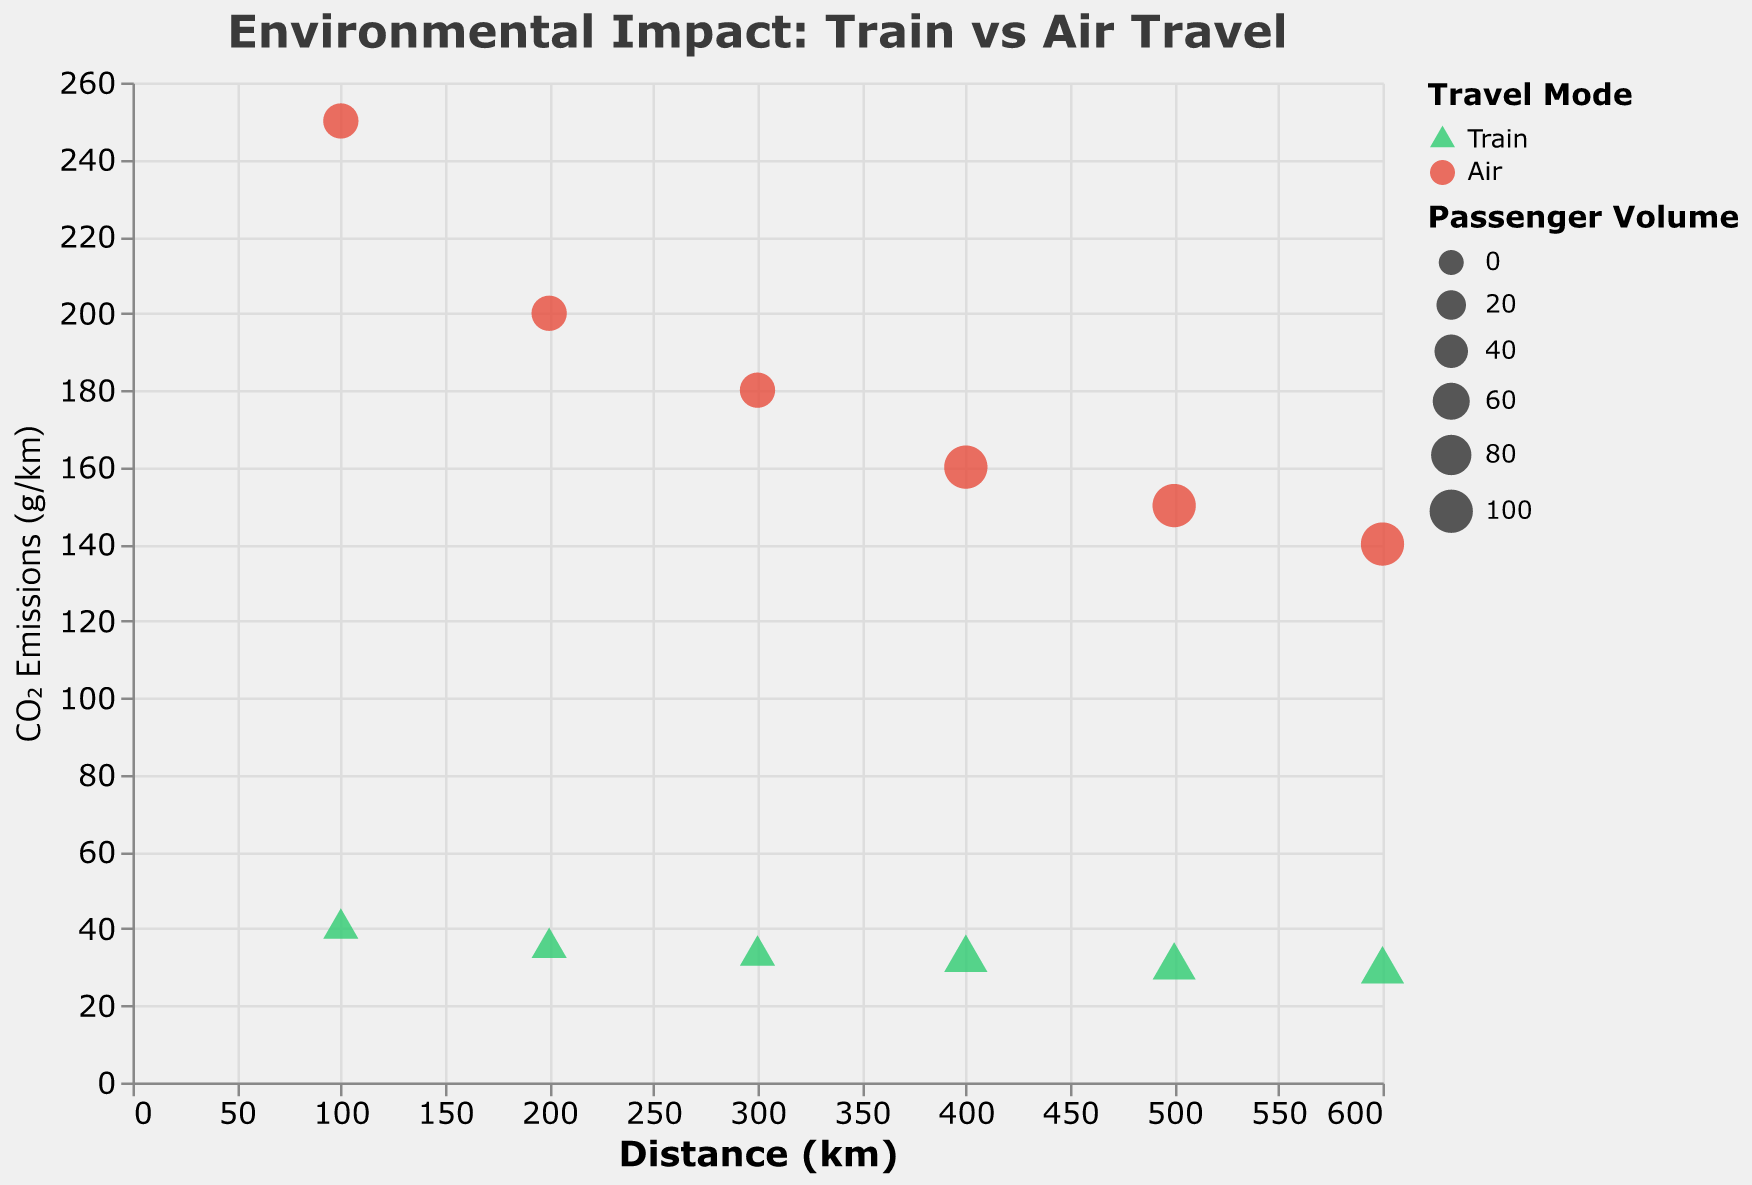What is the title of the figure? The title of the figure is displayed at the top of the plot and reads "Environmental Impact: Train vs Air Travel".
Answer: Environmental Impact: Train vs Air Travel How does the CO2 emissions per km for train travel change as the distance increases from 100 km to 600 km? The train’s CO2 emissions per km gradually decrease as the distance increases. From 40 g/km at 100 km to 29 g/km at 600 km.
Answer: It decreases What colors represent trains and air travel in the plot? The plot uses a color legend where green is used for trains and red is used for air travel.
Answer: Green and Red Which travel mode has higher CO2 emissions per km on a 300 km distance? For a 300 km distance, the CO2 emissions per km for air travel are 180 g/km, and for train travel are 33 g/km. Air travel has higher emissions.
Answer: Air travel How many different passenger volume sizes are used in the plot for train travel, and what are they? Train travel has two different passenger volume sizes shown by the sizes of the points: 50 and 100 passengers.
Answer: Two, 50 and 100 passengers What is the difference in CO2 emissions per km between train and air travel at a distance of 400 km? At 400 km, the CO2 emissions per km for train travel is 32 g/km, and for air travel is 160 g/km. The difference is 160 - 32 = 128 g/km.
Answer: 128 g/km Which mode of travel shows a more significant decrease in CO2 emissions per km as distance increases from 100 km to 600 km? Train travel starts at 40 g/km and drops to 29 g/km, showing an 11 g/km decrease. Air travel begins at 250 g/km and drops to 140 g/km, an overall decrease of 110 g/km. Air travel shows a more significant decrease.
Answer: Air travel By observing the plot, identify which mode of travel is generally more environmentally friendly based on CO2 emissions per km for distances ranging from 100 km to 600 km. Viewing the CO2 emissions per km across all distances presented, train travel consistently shows significantly lower emissions than air travel.
Answer: Train travel How does the plot express passenger volume, and what is the significance of its representation? Passenger volume is depicted by the size of the points on the plot. Larger points represent a higher passenger volume, with two sizes present: smaller for 50 passengers and larger for 100 passengers. This indicates the passenger capacity influences on the data points.
Answer: By point size, representing capacity impact 